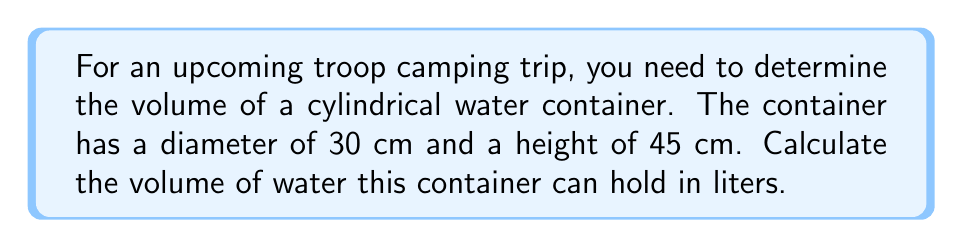Can you answer this question? Let's approach this step-by-step:

1) First, recall the formula for the volume of a cylinder:
   $$V = \pi r^2 h$$
   where $r$ is the radius of the base and $h$ is the height.

2) We're given the diameter (30 cm), but we need the radius. The radius is half the diameter:
   $$r = \frac{30}{2} = 15 \text{ cm}$$

3) Now we can substitute our values into the formula:
   $$V = \pi (15 \text{ cm})^2 (45 \text{ cm})$$

4) Let's calculate:
   $$V = \pi (225 \text{ cm}^2) (45 \text{ cm})$$
   $$V = 10,171.88... \text{ cm}^3$$

5) The question asks for the volume in liters. We know that 1 liter = 1000 cm³, so:
   $$V \text{ in liters} = \frac{10,171.88...}{1000} = 10.17188... \text{ liters}$$

6) Rounding to two decimal places for practical purposes:
   $$V \approx 10.17 \text{ liters}$$
Answer: 10.17 liters 